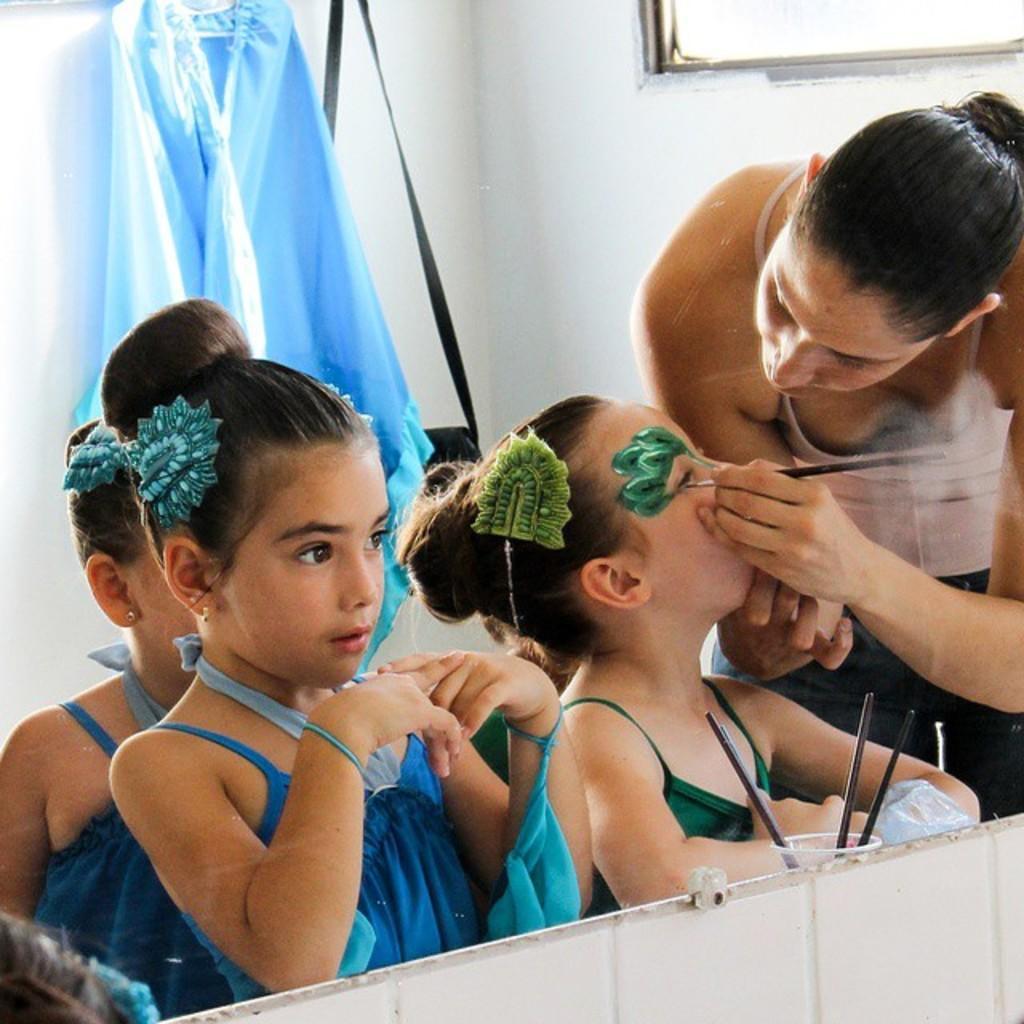Describe this image in one or two sentences. In this picture I can see there are few girls standing here and they are wearing blue frocks and there is a woman standing here and she is holding a brush and in the backdrop there is a wall and a window. 